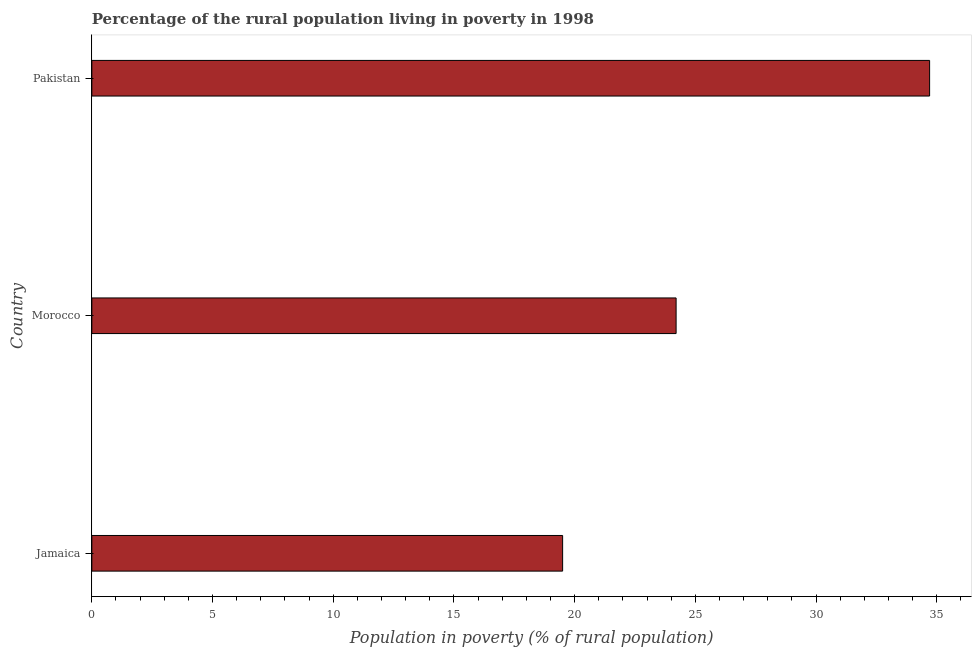Does the graph contain any zero values?
Your response must be concise. No. What is the title of the graph?
Provide a short and direct response. Percentage of the rural population living in poverty in 1998. What is the label or title of the X-axis?
Give a very brief answer. Population in poverty (% of rural population). What is the label or title of the Y-axis?
Your answer should be compact. Country. What is the percentage of rural population living below poverty line in Jamaica?
Your response must be concise. 19.5. Across all countries, what is the maximum percentage of rural population living below poverty line?
Make the answer very short. 34.7. Across all countries, what is the minimum percentage of rural population living below poverty line?
Ensure brevity in your answer.  19.5. In which country was the percentage of rural population living below poverty line minimum?
Give a very brief answer. Jamaica. What is the sum of the percentage of rural population living below poverty line?
Ensure brevity in your answer.  78.4. What is the average percentage of rural population living below poverty line per country?
Ensure brevity in your answer.  26.13. What is the median percentage of rural population living below poverty line?
Your answer should be very brief. 24.2. What is the ratio of the percentage of rural population living below poverty line in Jamaica to that in Morocco?
Make the answer very short. 0.81. What is the difference between the highest and the second highest percentage of rural population living below poverty line?
Your response must be concise. 10.5. Is the sum of the percentage of rural population living below poverty line in Jamaica and Pakistan greater than the maximum percentage of rural population living below poverty line across all countries?
Offer a terse response. Yes. In how many countries, is the percentage of rural population living below poverty line greater than the average percentage of rural population living below poverty line taken over all countries?
Keep it short and to the point. 1. How many bars are there?
Ensure brevity in your answer.  3. Are all the bars in the graph horizontal?
Your answer should be compact. Yes. What is the difference between two consecutive major ticks on the X-axis?
Your answer should be very brief. 5. What is the Population in poverty (% of rural population) of Jamaica?
Give a very brief answer. 19.5. What is the Population in poverty (% of rural population) in Morocco?
Offer a very short reply. 24.2. What is the Population in poverty (% of rural population) of Pakistan?
Keep it short and to the point. 34.7. What is the difference between the Population in poverty (% of rural population) in Jamaica and Morocco?
Provide a short and direct response. -4.7. What is the difference between the Population in poverty (% of rural population) in Jamaica and Pakistan?
Give a very brief answer. -15.2. What is the difference between the Population in poverty (% of rural population) in Morocco and Pakistan?
Ensure brevity in your answer.  -10.5. What is the ratio of the Population in poverty (% of rural population) in Jamaica to that in Morocco?
Make the answer very short. 0.81. What is the ratio of the Population in poverty (% of rural population) in Jamaica to that in Pakistan?
Ensure brevity in your answer.  0.56. What is the ratio of the Population in poverty (% of rural population) in Morocco to that in Pakistan?
Make the answer very short. 0.7. 